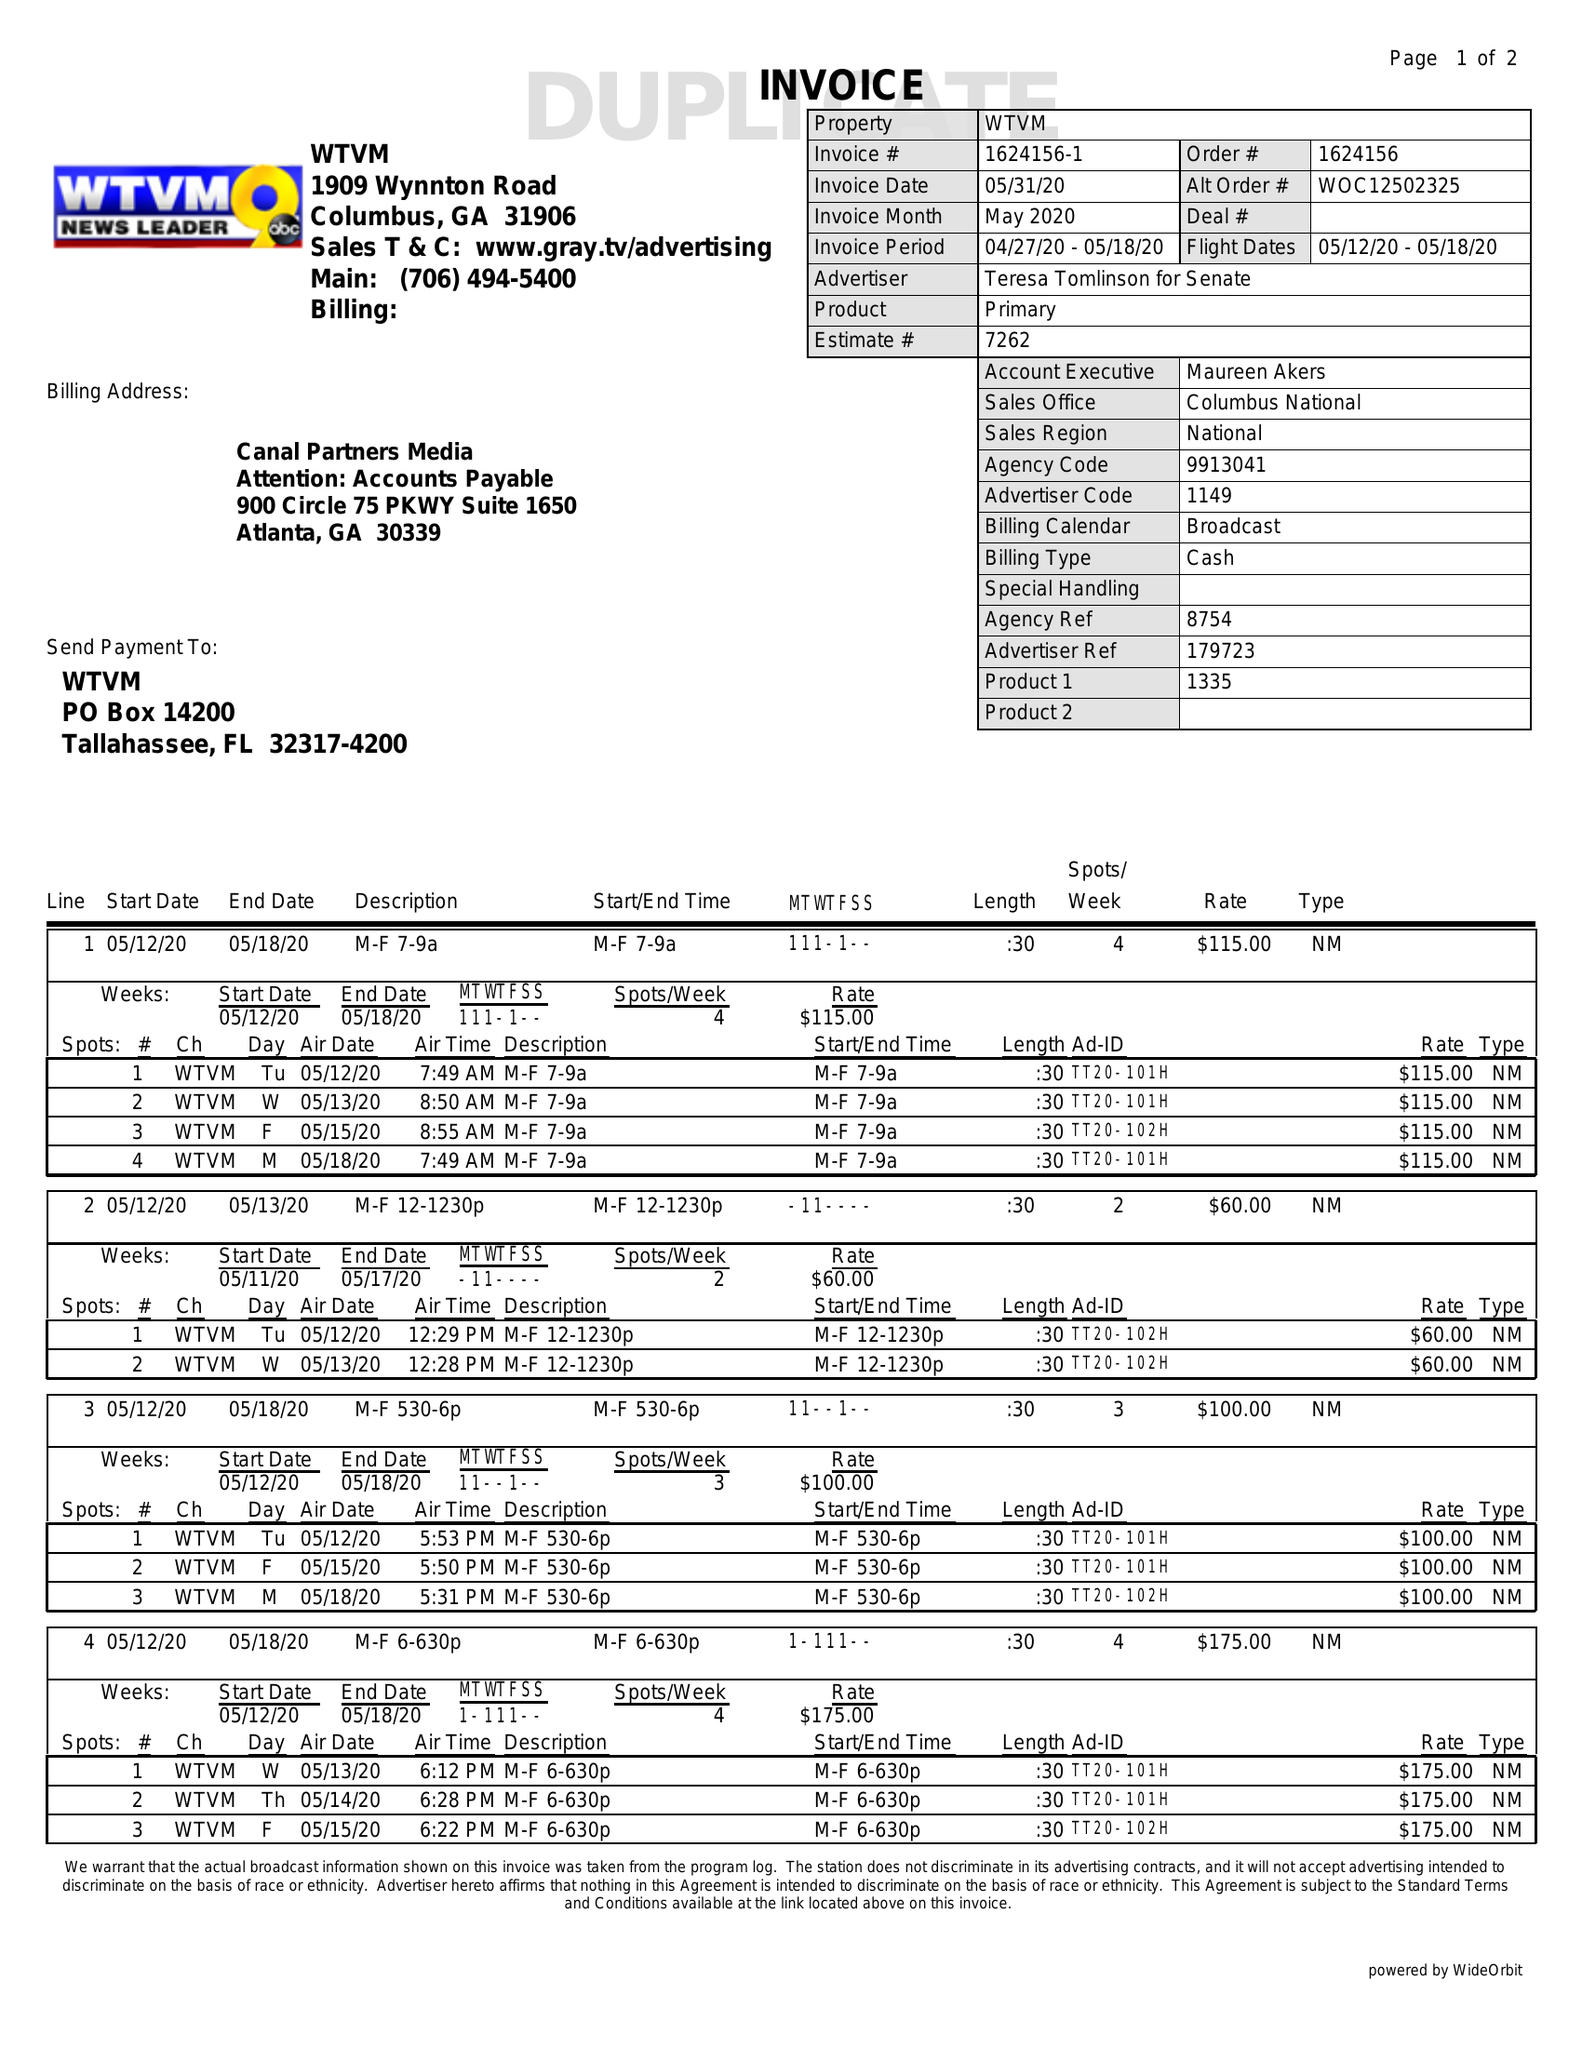What is the value for the gross_amount?
Answer the question using a single word or phrase. 1855.00 